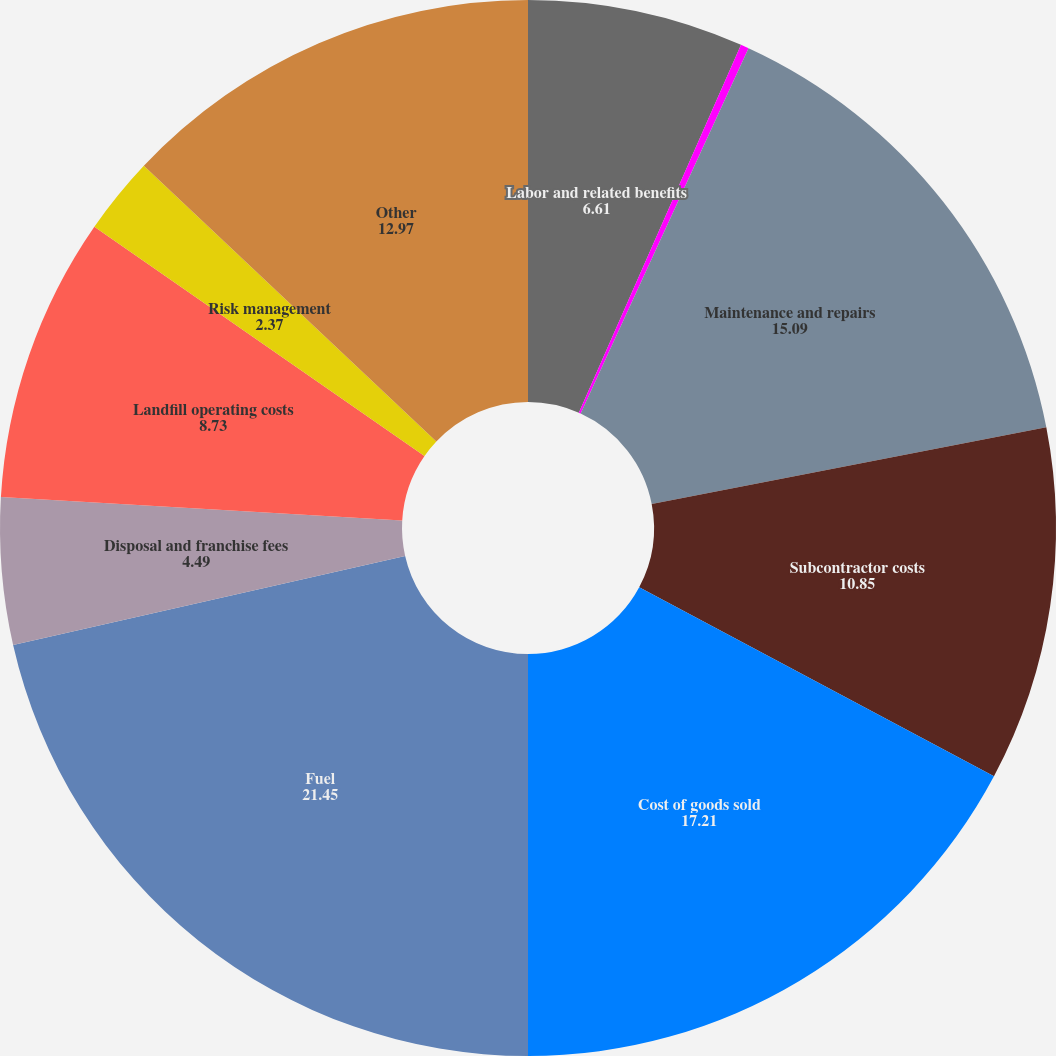Convert chart to OTSL. <chart><loc_0><loc_0><loc_500><loc_500><pie_chart><fcel>Labor and related benefits<fcel>Transfer and disposal costs<fcel>Maintenance and repairs<fcel>Subcontractor costs<fcel>Cost of goods sold<fcel>Fuel<fcel>Disposal and franchise fees<fcel>Landfill operating costs<fcel>Risk management<fcel>Other<nl><fcel>6.61%<fcel>0.25%<fcel>15.09%<fcel>10.85%<fcel>17.21%<fcel>21.45%<fcel>4.49%<fcel>8.73%<fcel>2.37%<fcel>12.97%<nl></chart> 